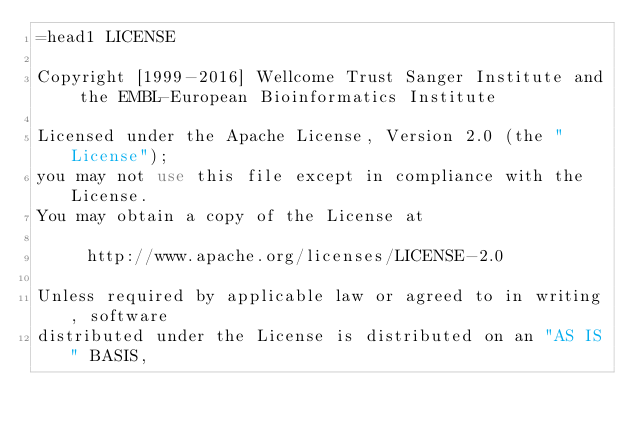Convert code to text. <code><loc_0><loc_0><loc_500><loc_500><_Perl_>=head1 LICENSE

Copyright [1999-2016] Wellcome Trust Sanger Institute and the EMBL-European Bioinformatics Institute

Licensed under the Apache License, Version 2.0 (the "License");
you may not use this file except in compliance with the License.
You may obtain a copy of the License at

     http://www.apache.org/licenses/LICENSE-2.0

Unless required by applicable law or agreed to in writing, software
distributed under the License is distributed on an "AS IS" BASIS,</code> 